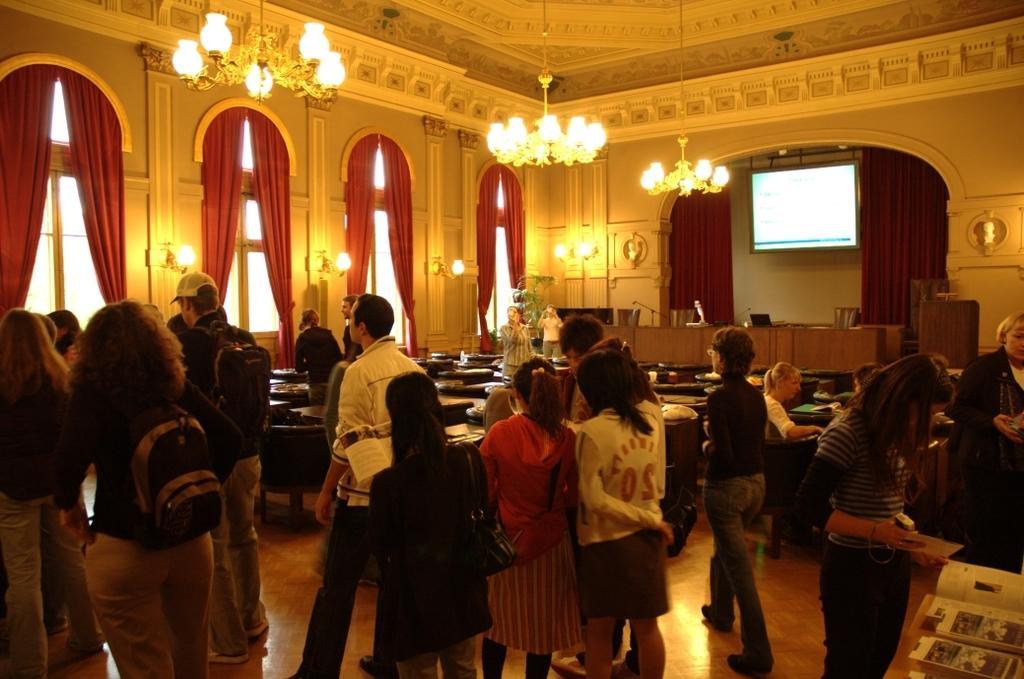Please provide a concise description of this image. This image is taken inside the building. In this image we can see few people standing on the floor. Image also consists of tables with chairs, lights, screen, podium and windows with curtains. At the top we can see ceiling lights to the roof. 